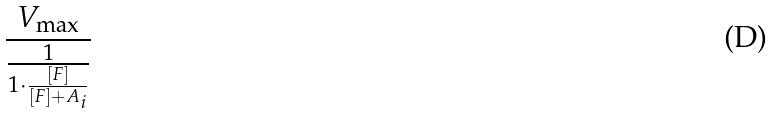<formula> <loc_0><loc_0><loc_500><loc_500>\frac { V _ { \max } } { \frac { 1 } { 1 \cdot \frac { [ F ] } { [ F ] + A _ { i } } } }</formula> 